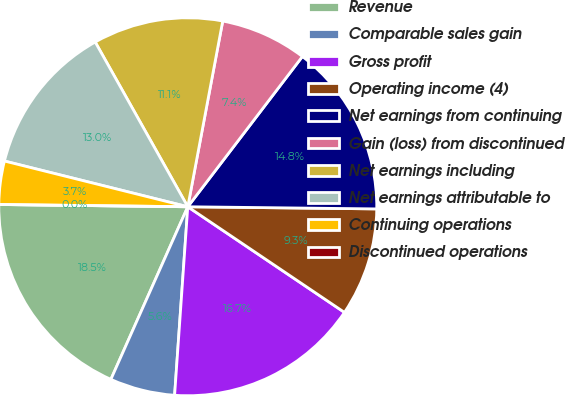<chart> <loc_0><loc_0><loc_500><loc_500><pie_chart><fcel>Revenue<fcel>Comparable sales gain<fcel>Gross profit<fcel>Operating income (4)<fcel>Net earnings from continuing<fcel>Gain (loss) from discontinued<fcel>Net earnings including<fcel>Net earnings attributable to<fcel>Continuing operations<fcel>Discontinued operations<nl><fcel>18.52%<fcel>5.56%<fcel>16.67%<fcel>9.26%<fcel>14.81%<fcel>7.41%<fcel>11.11%<fcel>12.96%<fcel>3.7%<fcel>0.0%<nl></chart> 